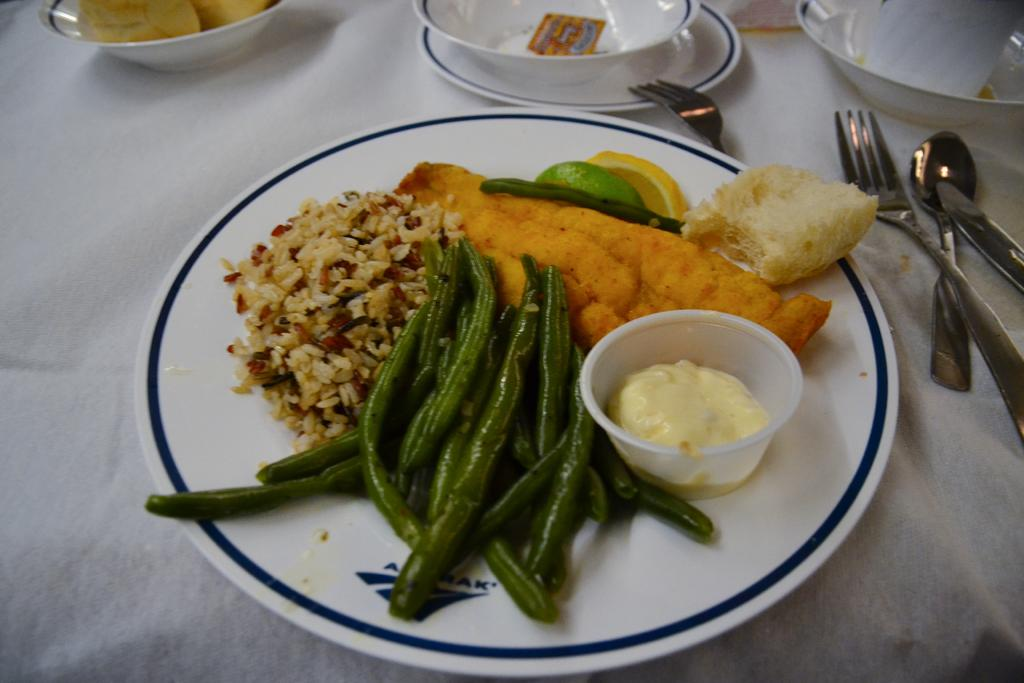What is on the plate that is visible in the image? There is a plate with food items in the image. Where is the plate located in the image? The plate is on a table in the image. What utensils can be seen in the image? There are forks and spoons in the image. What else is present on the table besides the plate? There are bowls in the image. What type of meat is being discussed at the meeting in the image? There is no meeting or meat present in the image; it features a plate with food items, utensils, and bowls on a table. 